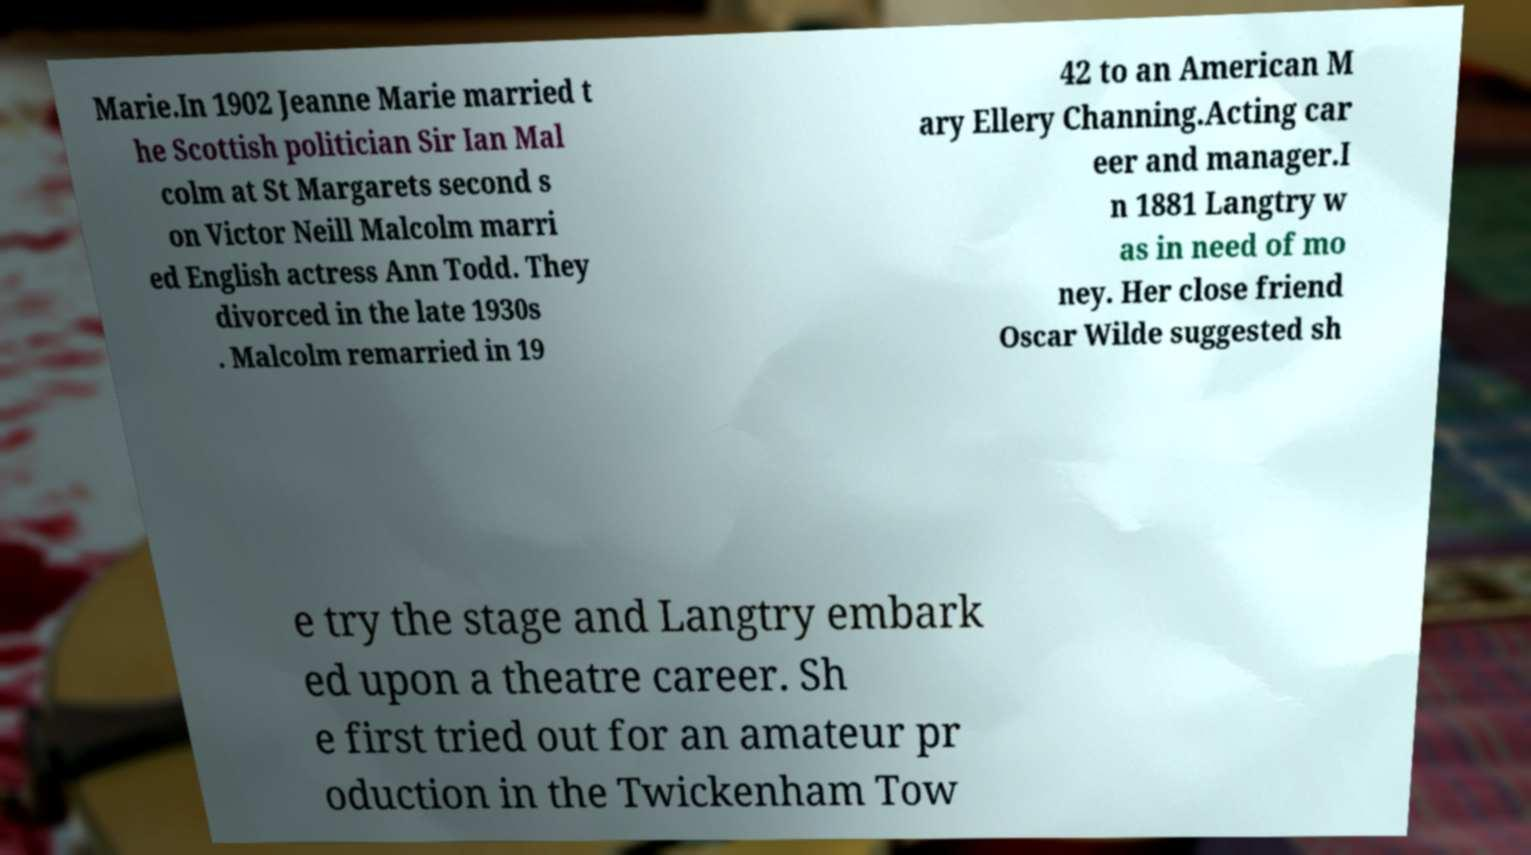Can you accurately transcribe the text from the provided image for me? Marie.In 1902 Jeanne Marie married t he Scottish politician Sir Ian Mal colm at St Margarets second s on Victor Neill Malcolm marri ed English actress Ann Todd. They divorced in the late 1930s . Malcolm remarried in 19 42 to an American M ary Ellery Channing.Acting car eer and manager.I n 1881 Langtry w as in need of mo ney. Her close friend Oscar Wilde suggested sh e try the stage and Langtry embark ed upon a theatre career. Sh e first tried out for an amateur pr oduction in the Twickenham Tow 